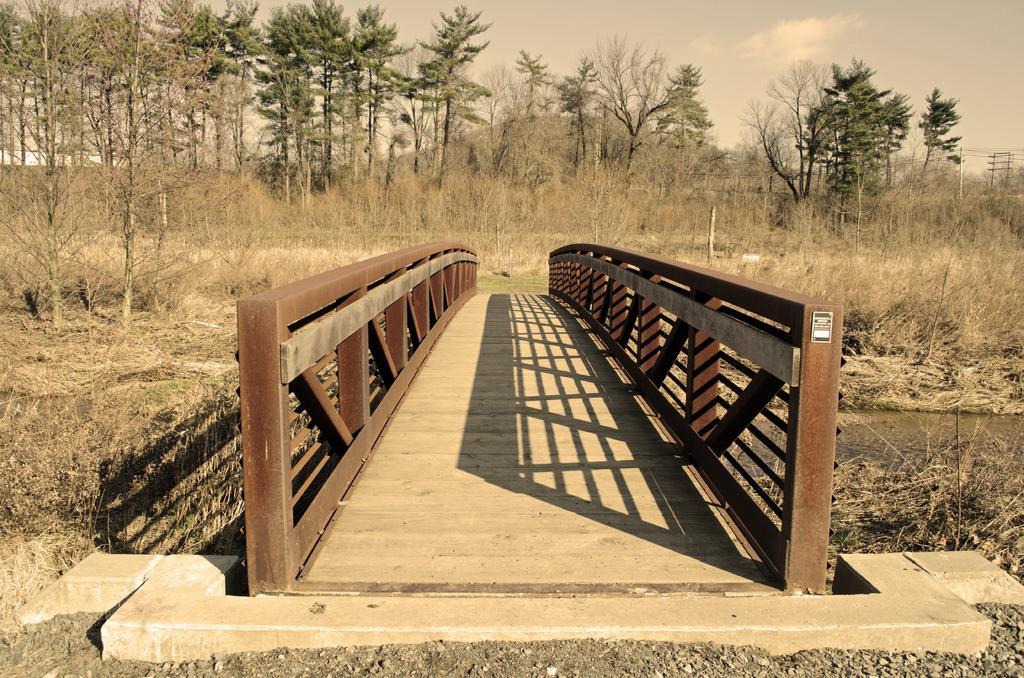In one or two sentences, can you explain what this image depicts? In this picture, we can see the ground with trees, plants and grass, we can see the wooden bridge, poles, wires, water and the sky with clouds. 